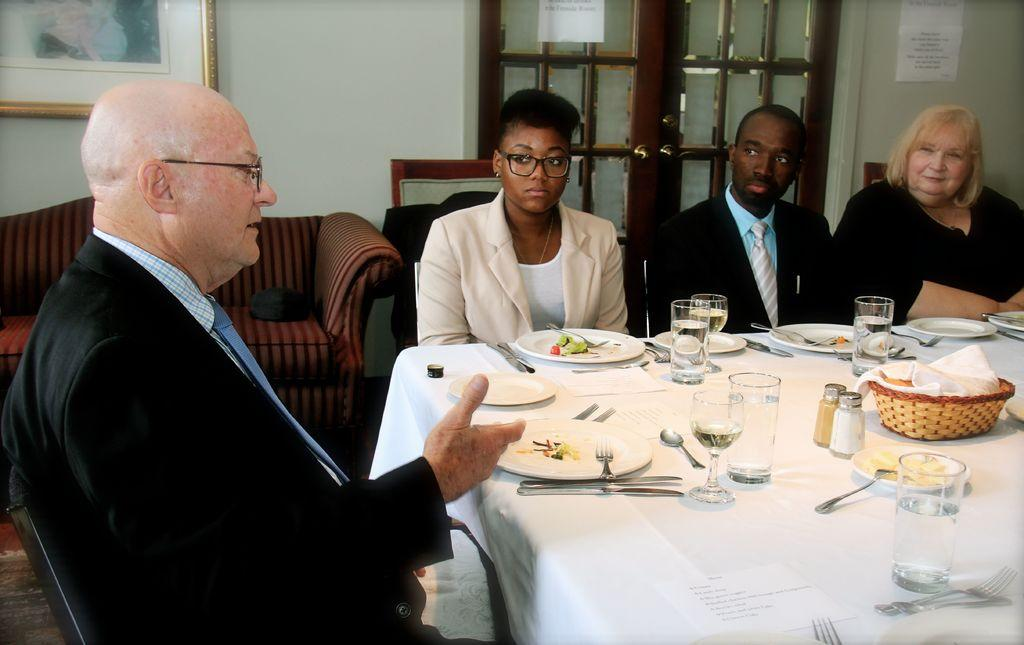What are the people in the image doing? People are sitting on chairs in the image. What is on the table in the image? There is a glass, a plate, and a spoon on the table in the image. What can be seen in the background of the image? There is a sofa, a door, and a frame on the wall in the background. What type of cracker is being used in the battle depicted in the image? There is no battle depicted in the image, and therefore no crackers are involved. Can you tell me how many cups are on the table in the image? There is no cup present on the table in the image. 